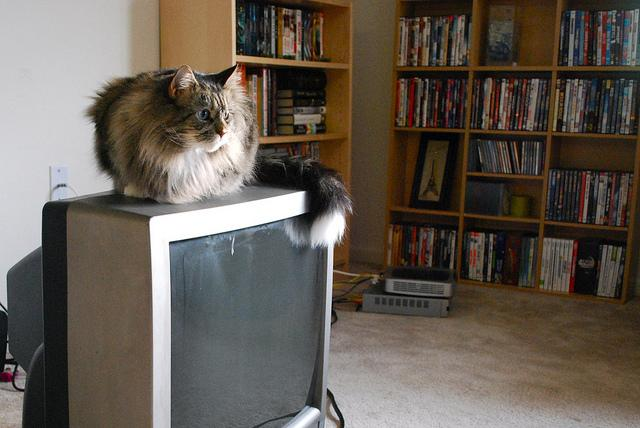What is the item that the cat is on top of used for? watching television 